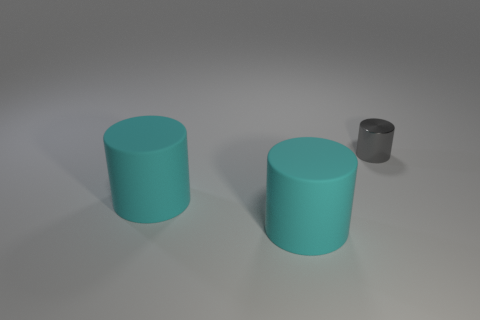Add 1 tiny shiny cylinders. How many objects exist? 4 Subtract 0 brown blocks. How many objects are left? 3 Subtract all big purple rubber balls. Subtract all small gray metal cylinders. How many objects are left? 2 Add 3 cylinders. How many cylinders are left? 6 Add 2 matte cylinders. How many matte cylinders exist? 4 